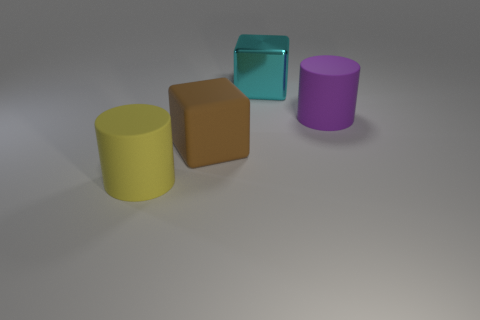Are there any other things that have the same material as the large cyan thing?
Your response must be concise. No. What number of objects are rubber cylinders that are behind the yellow matte cylinder or small spheres?
Make the answer very short. 1. What material is the large cyan block?
Give a very brief answer. Metal. There is a large object that is behind the thing on the right side of the large shiny block; what is its shape?
Give a very brief answer. Cube. There is a large purple object; are there any objects in front of it?
Provide a succinct answer. Yes. The shiny cube is what color?
Offer a terse response. Cyan. Is there a yellow rubber ball that has the same size as the yellow rubber cylinder?
Provide a short and direct response. No. What is the cylinder on the right side of the yellow rubber cylinder made of?
Keep it short and to the point. Rubber. Are there the same number of large cylinders that are behind the purple object and large rubber cylinders that are behind the big cyan object?
Your response must be concise. Yes. How many blocks have the same color as the metal thing?
Your response must be concise. 0. 